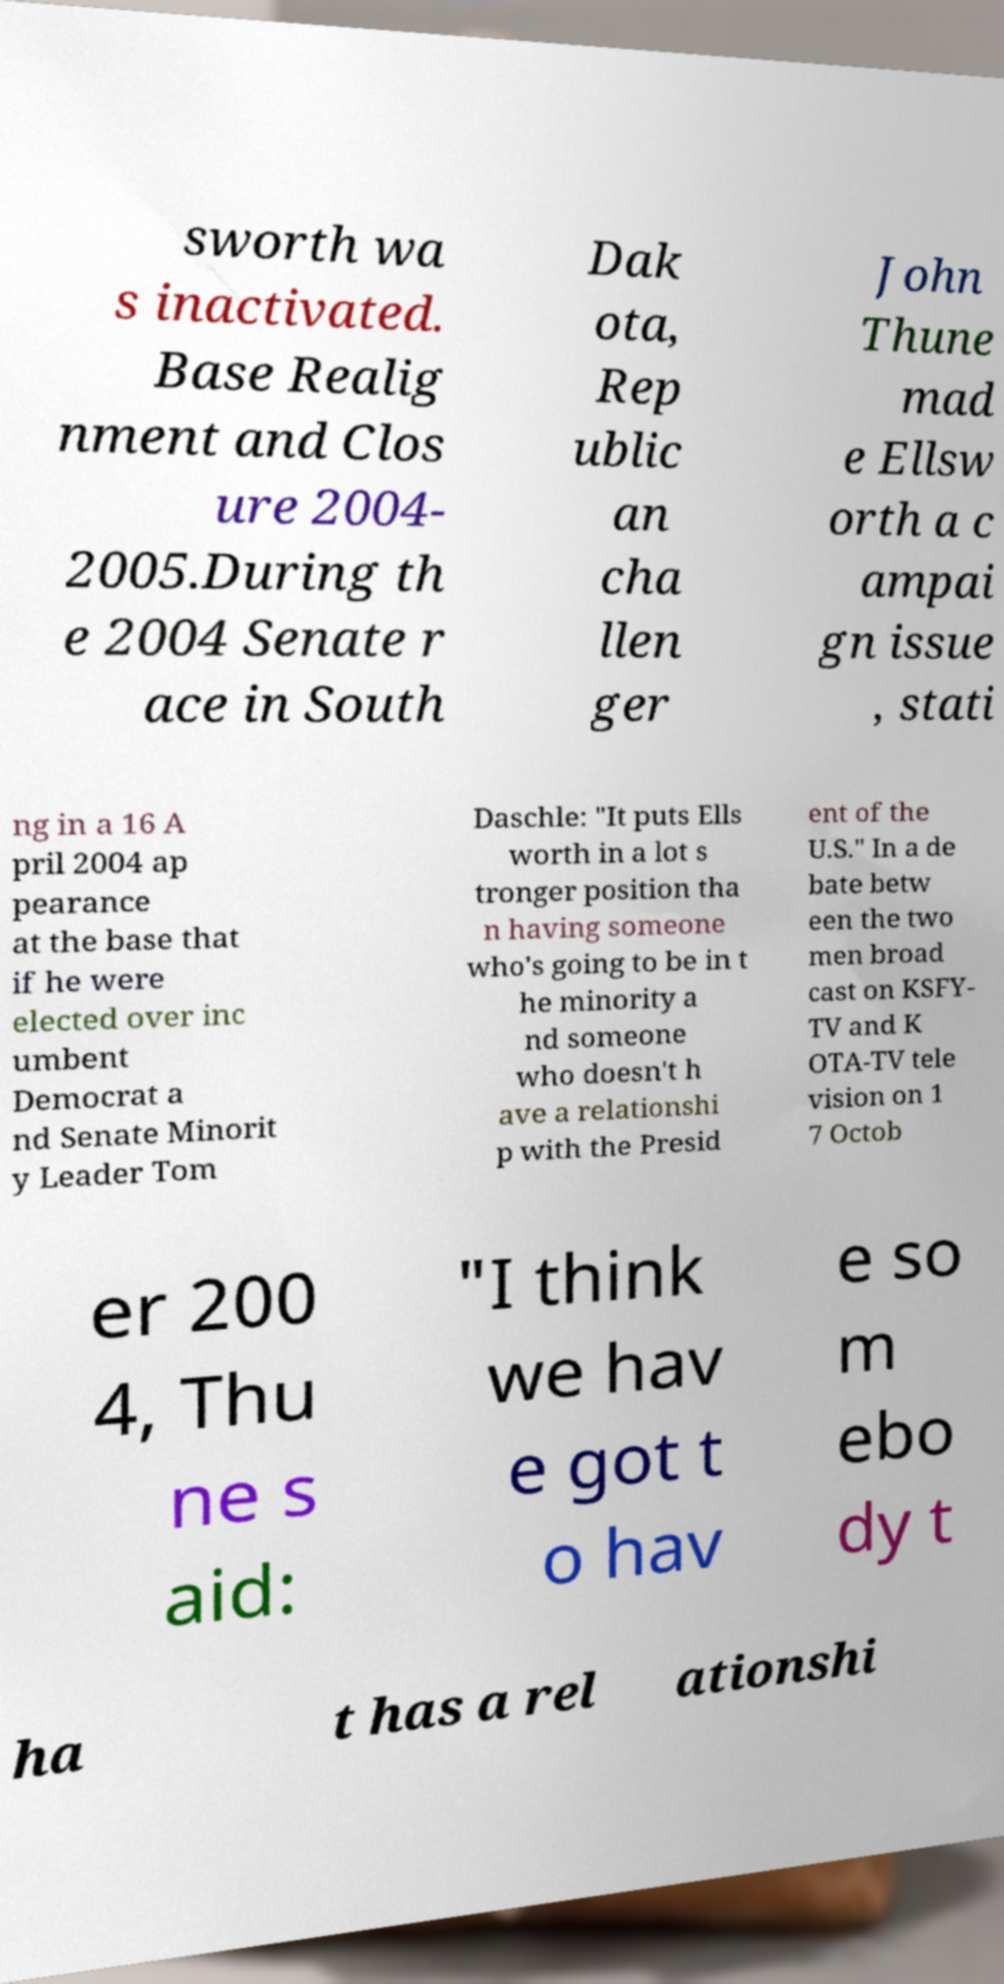I need the written content from this picture converted into text. Can you do that? sworth wa s inactivated. Base Realig nment and Clos ure 2004- 2005.During th e 2004 Senate r ace in South Dak ota, Rep ublic an cha llen ger John Thune mad e Ellsw orth a c ampai gn issue , stati ng in a 16 A pril 2004 ap pearance at the base that if he were elected over inc umbent Democrat a nd Senate Minorit y Leader Tom Daschle: "It puts Ells worth in a lot s tronger position tha n having someone who's going to be in t he minority a nd someone who doesn't h ave a relationshi p with the Presid ent of the U.S." In a de bate betw een the two men broad cast on KSFY- TV and K OTA-TV tele vision on 1 7 Octob er 200 4, Thu ne s aid: "I think we hav e got t o hav e so m ebo dy t ha t has a rel ationshi 